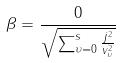Convert formula to latex. <formula><loc_0><loc_0><loc_500><loc_500>\beta = \frac { 0 } { \sqrt { \sum _ { \upsilon = 0 } ^ { s } \frac { j ^ { 2 } } { v _ { \upsilon } ^ { 2 } } } }</formula> 